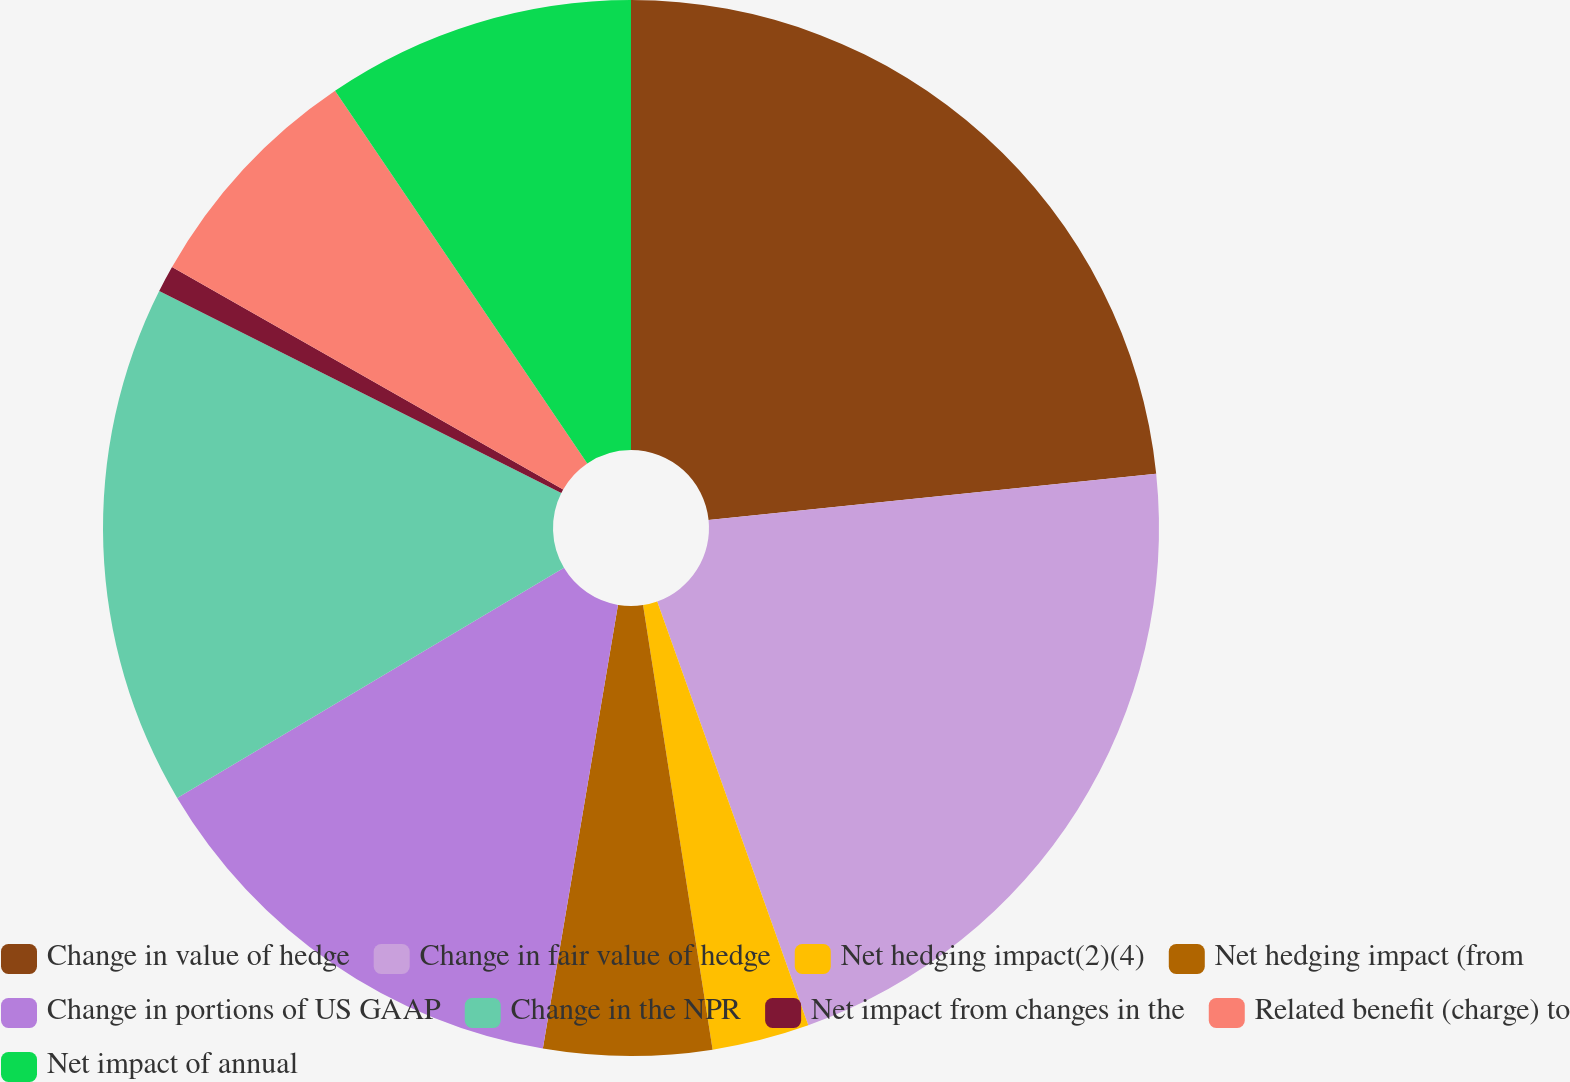Convert chart. <chart><loc_0><loc_0><loc_500><loc_500><pie_chart><fcel>Change in value of hedge<fcel>Change in fair value of hedge<fcel>Net hedging impact(2)(4)<fcel>Net hedging impact (from<fcel>Change in portions of US GAAP<fcel>Change in the NPR<fcel>Net impact from changes in the<fcel>Related benefit (charge) to<fcel>Net impact of annual<nl><fcel>23.36%<fcel>21.19%<fcel>2.98%<fcel>5.14%<fcel>13.79%<fcel>15.95%<fcel>0.82%<fcel>7.3%<fcel>9.47%<nl></chart> 